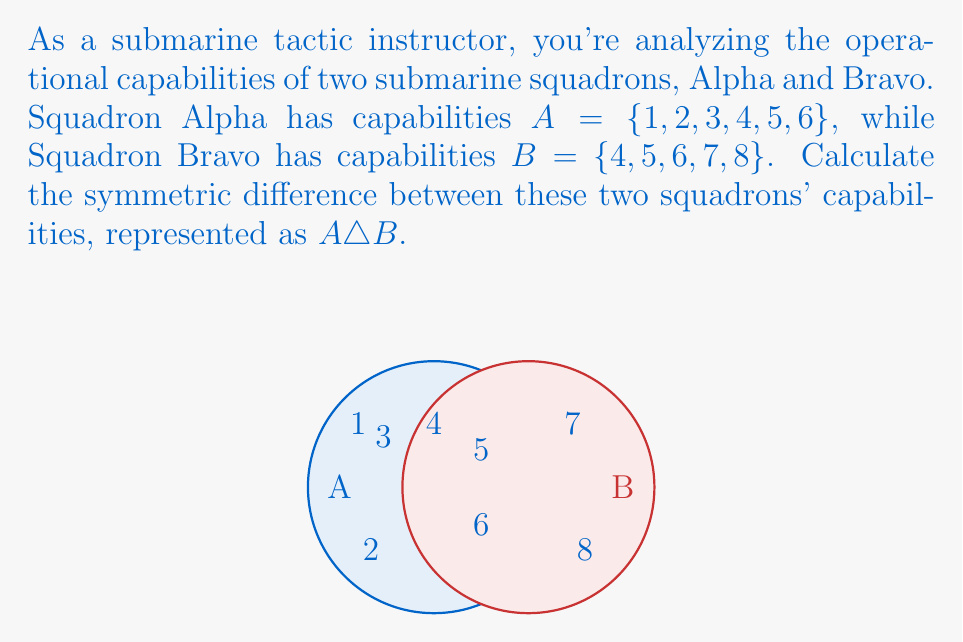Provide a solution to this math problem. To find the symmetric difference between sets A and B, we need to follow these steps:

1) Recall that the symmetric difference $A \triangle B$ is defined as $(A \cup B) \setminus (A \cap B)$, or equivalently, $(A \setminus B) \cup (B \setminus A)$.

2) First, let's find $A \setminus B$:
   $A \setminus B = \{1, 2, 3\}$

3) Next, let's find $B \setminus A$:
   $B \setminus A = \{7, 8\}$

4) Now, we can find the symmetric difference by taking the union of these two sets:
   $A \triangle B = (A \setminus B) \cup (B \setminus A) = \{1, 2, 3\} \cup \{7, 8\}$

5) Therefore, the final result is:
   $A \triangle B = \{1, 2, 3, 7, 8\}$

This symmetric difference represents the capabilities that are unique to each squadron, i.e., capabilities that one squadron has but the other doesn't.
Answer: $\{1, 2, 3, 7, 8\}$ 